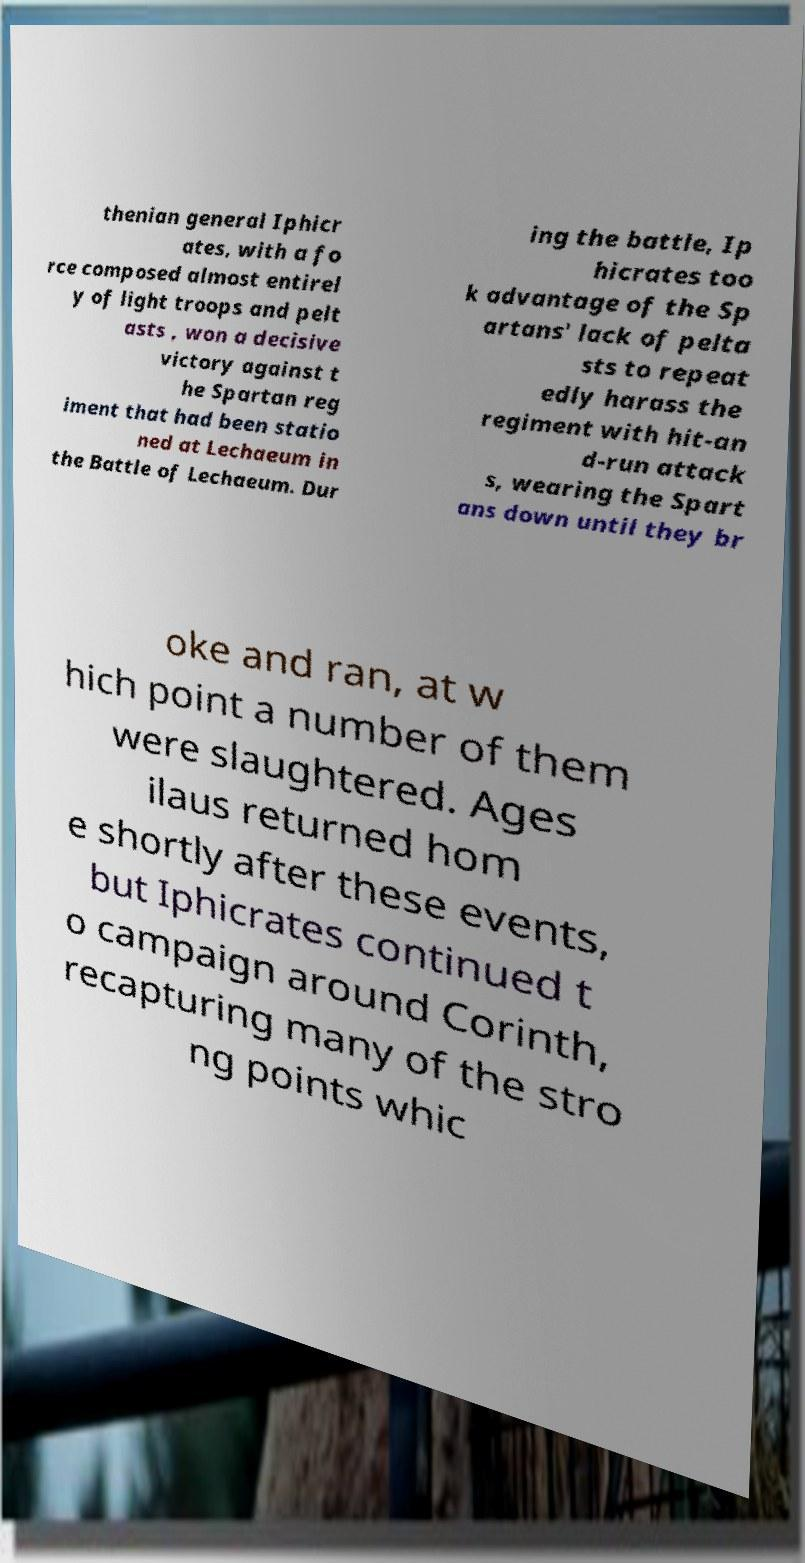I need the written content from this picture converted into text. Can you do that? thenian general Iphicr ates, with a fo rce composed almost entirel y of light troops and pelt asts , won a decisive victory against t he Spartan reg iment that had been statio ned at Lechaeum in the Battle of Lechaeum. Dur ing the battle, Ip hicrates too k advantage of the Sp artans' lack of pelta sts to repeat edly harass the regiment with hit-an d-run attack s, wearing the Spart ans down until they br oke and ran, at w hich point a number of them were slaughtered. Ages ilaus returned hom e shortly after these events, but Iphicrates continued t o campaign around Corinth, recapturing many of the stro ng points whic 